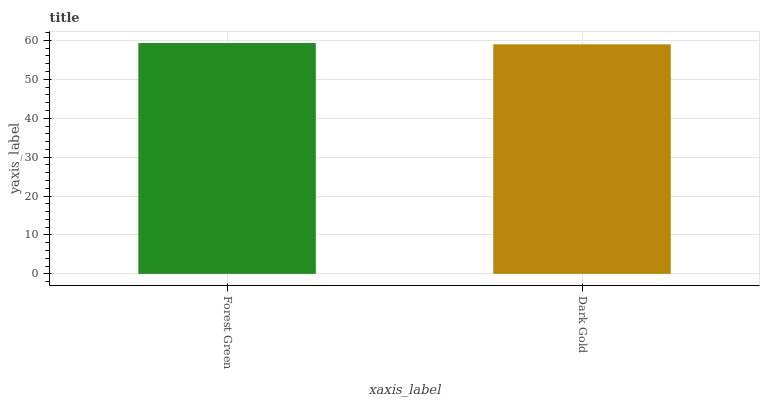Is Dark Gold the minimum?
Answer yes or no. Yes. Is Forest Green the maximum?
Answer yes or no. Yes. Is Dark Gold the maximum?
Answer yes or no. No. Is Forest Green greater than Dark Gold?
Answer yes or no. Yes. Is Dark Gold less than Forest Green?
Answer yes or no. Yes. Is Dark Gold greater than Forest Green?
Answer yes or no. No. Is Forest Green less than Dark Gold?
Answer yes or no. No. Is Forest Green the high median?
Answer yes or no. Yes. Is Dark Gold the low median?
Answer yes or no. Yes. Is Dark Gold the high median?
Answer yes or no. No. Is Forest Green the low median?
Answer yes or no. No. 